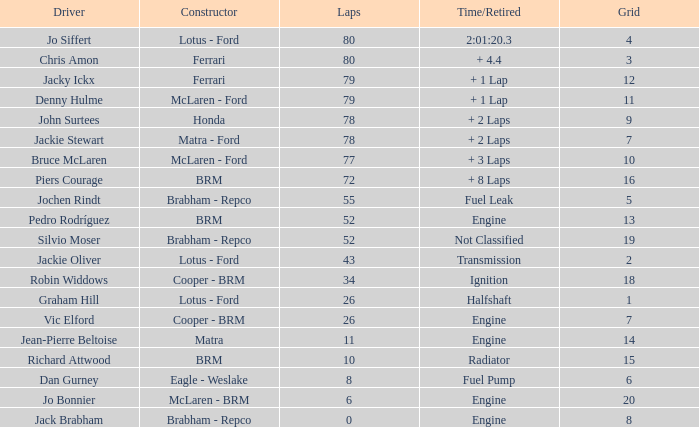I'm looking to parse the entire table for insights. Could you assist me with that? {'header': ['Driver', 'Constructor', 'Laps', 'Time/Retired', 'Grid'], 'rows': [['Jo Siffert', 'Lotus - Ford', '80', '2:01:20.3', '4'], ['Chris Amon', 'Ferrari', '80', '+ 4.4', '3'], ['Jacky Ickx', 'Ferrari', '79', '+ 1 Lap', '12'], ['Denny Hulme', 'McLaren - Ford', '79', '+ 1 Lap', '11'], ['John Surtees', 'Honda', '78', '+ 2 Laps', '9'], ['Jackie Stewart', 'Matra - Ford', '78', '+ 2 Laps', '7'], ['Bruce McLaren', 'McLaren - Ford', '77', '+ 3 Laps', '10'], ['Piers Courage', 'BRM', '72', '+ 8 Laps', '16'], ['Jochen Rindt', 'Brabham - Repco', '55', 'Fuel Leak', '5'], ['Pedro Rodríguez', 'BRM', '52', 'Engine', '13'], ['Silvio Moser', 'Brabham - Repco', '52', 'Not Classified', '19'], ['Jackie Oliver', 'Lotus - Ford', '43', 'Transmission', '2'], ['Robin Widdows', 'Cooper - BRM', '34', 'Ignition', '18'], ['Graham Hill', 'Lotus - Ford', '26', 'Halfshaft', '1'], ['Vic Elford', 'Cooper - BRM', '26', 'Engine', '7'], ['Jean-Pierre Beltoise', 'Matra', '11', 'Engine', '14'], ['Richard Attwood', 'BRM', '10', 'Radiator', '15'], ['Dan Gurney', 'Eagle - Weslake', '8', 'Fuel Pump', '6'], ['Jo Bonnier', 'McLaren - BRM', '6', 'Engine', '20'], ['Jack Brabham', 'Brabham - Repco', '0', 'Engine', '8']]} When richard attwood is a driver for brm, what is the total number of laps completed? 10.0. 